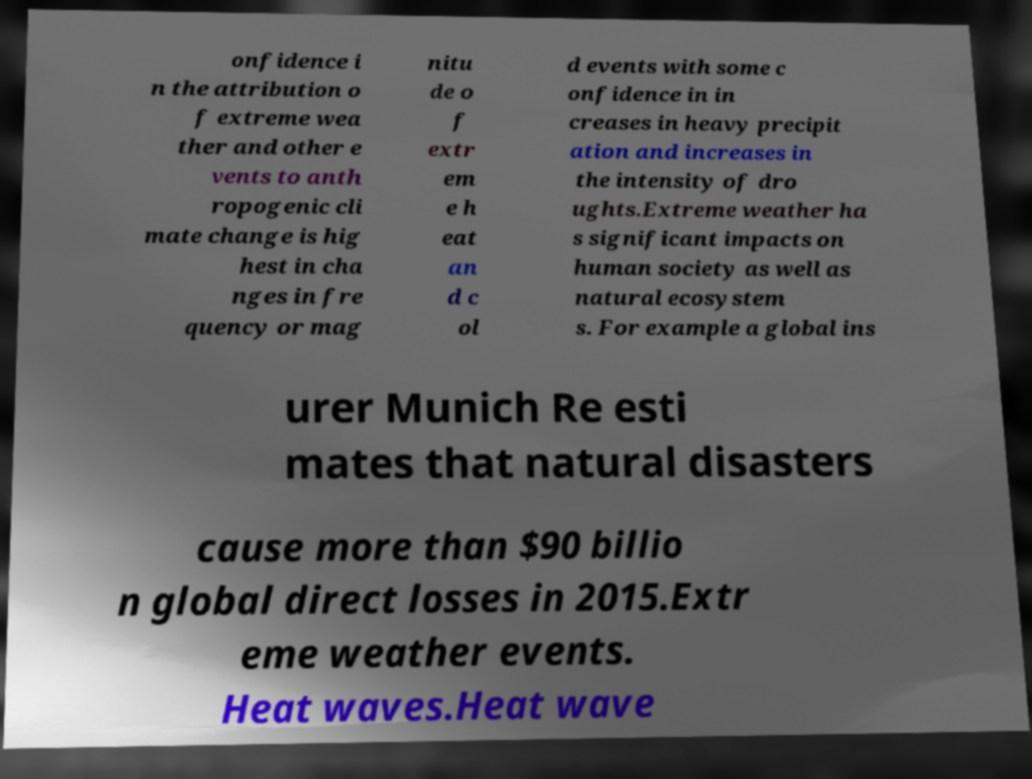Could you extract and type out the text from this image? onfidence i n the attribution o f extreme wea ther and other e vents to anth ropogenic cli mate change is hig hest in cha nges in fre quency or mag nitu de o f extr em e h eat an d c ol d events with some c onfidence in in creases in heavy precipit ation and increases in the intensity of dro ughts.Extreme weather ha s significant impacts on human society as well as natural ecosystem s. For example a global ins urer Munich Re esti mates that natural disasters cause more than $90 billio n global direct losses in 2015.Extr eme weather events. Heat waves.Heat wave 